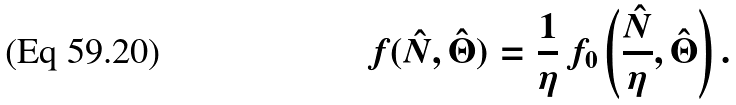Convert formula to latex. <formula><loc_0><loc_0><loc_500><loc_500>f ( \hat { N } , \hat { \Theta } ) = \frac { 1 } { \eta } \, f _ { 0 } \left ( \frac { \hat { N } } { \eta } , \hat { \Theta } \right ) .</formula> 